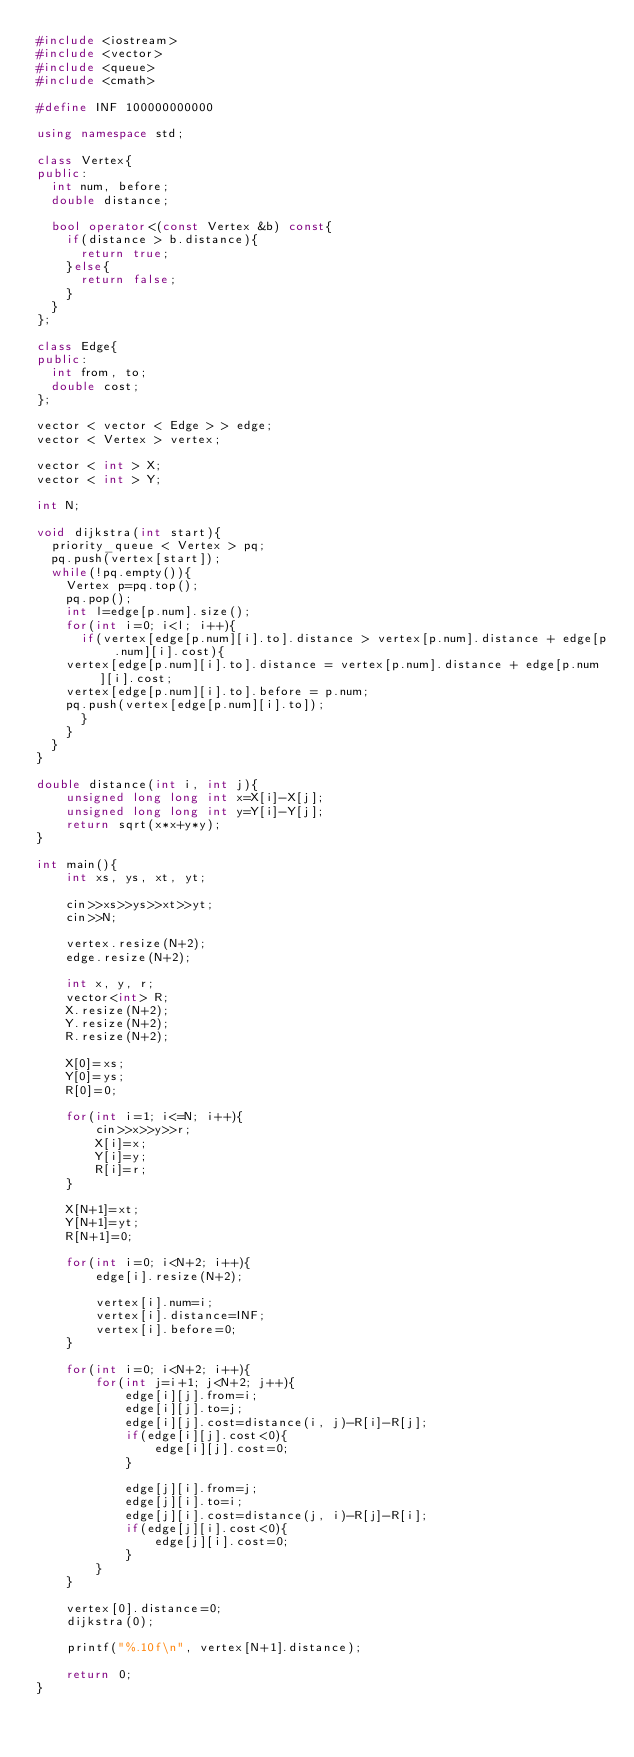<code> <loc_0><loc_0><loc_500><loc_500><_C++_>#include <iostream>
#include <vector>
#include <queue>
#include <cmath>

#define INF 100000000000

using namespace std;

class Vertex{
public:
  int num, before;
  double distance;

  bool operator<(const Vertex &b) const{
    if(distance > b.distance){
      return true;
    }else{
      return false;
    }
  }
};

class Edge{
public:
  int from, to;
  double cost;
};

vector < vector < Edge > > edge;
vector < Vertex > vertex;

vector < int > X;
vector < int > Y;

int N;

void dijkstra(int start){
  priority_queue < Vertex > pq;
  pq.push(vertex[start]);
  while(!pq.empty()){
    Vertex p=pq.top();
    pq.pop();
	int l=edge[p.num].size();
    for(int i=0; i<l; i++){
      if(vertex[edge[p.num][i].to].distance > vertex[p.num].distance + edge[p.num][i].cost){
	vertex[edge[p.num][i].to].distance = vertex[p.num].distance + edge[p.num][i].cost;
	vertex[edge[p.num][i].to].before = p.num;
	pq.push(vertex[edge[p.num][i].to]);
      }
    }
  }
}

double distance(int i, int j){
	unsigned long long int x=X[i]-X[j];
	unsigned long long int y=Y[i]-Y[j];
	return sqrt(x*x+y*y);
}

int main(){
	int xs, ys, xt, yt;

	cin>>xs>>ys>>xt>>yt;
	cin>>N;

	vertex.resize(N+2);
	edge.resize(N+2);
	
	int x, y, r;
	vector<int> R;
	X.resize(N+2);
	Y.resize(N+2);
	R.resize(N+2);

	X[0]=xs;
	Y[0]=ys;
	R[0]=0;

	for(int i=1; i<=N; i++){
		cin>>x>>y>>r;
		X[i]=x;
		Y[i]=y;
		R[i]=r;
	}

	X[N+1]=xt;
	Y[N+1]=yt;
	R[N+1]=0;

	for(int i=0; i<N+2; i++){
		edge[i].resize(N+2);

		vertex[i].num=i;
		vertex[i].distance=INF;
		vertex[i].before=0;
	}

	for(int i=0; i<N+2; i++){
		for(int j=i+1; j<N+2; j++){
			edge[i][j].from=i;
			edge[i][j].to=j;
			edge[i][j].cost=distance(i, j)-R[i]-R[j];
			if(edge[i][j].cost<0){
				edge[i][j].cost=0;
			}

			edge[j][i].from=j;
			edge[j][i].to=i;
			edge[j][i].cost=distance(j, i)-R[j]-R[i];
			if(edge[j][i].cost<0){
				edge[j][i].cost=0;
			}
		}
	}

	vertex[0].distance=0;
	dijkstra(0);

	printf("%.10f\n", vertex[N+1].distance);

	return 0;
}
</code> 